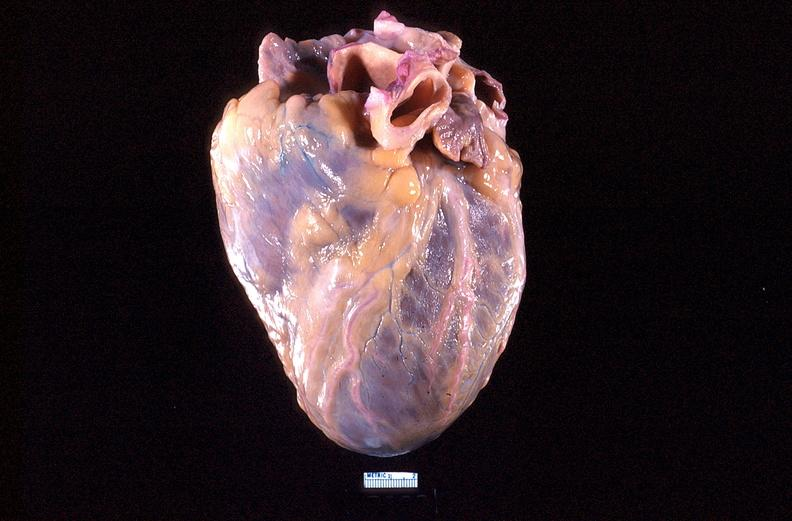s slide present?
Answer the question using a single word or phrase. No 